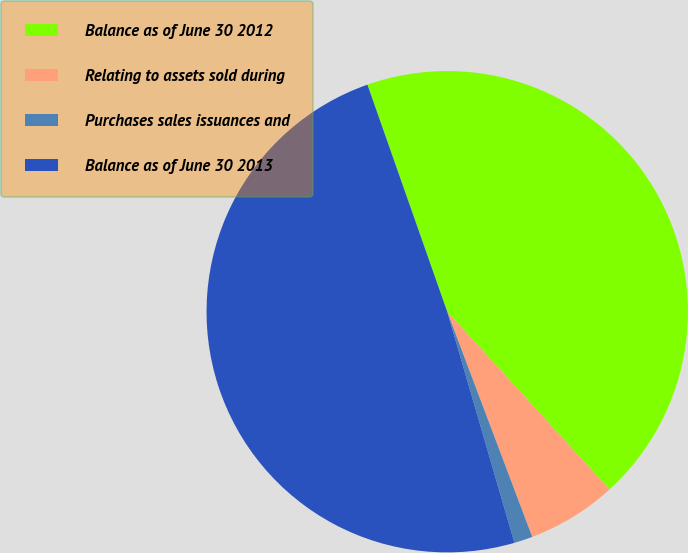Convert chart. <chart><loc_0><loc_0><loc_500><loc_500><pie_chart><fcel>Balance as of June 30 2012<fcel>Relating to assets sold during<fcel>Purchases sales issuances and<fcel>Balance as of June 30 2013<nl><fcel>43.61%<fcel>6.03%<fcel>1.24%<fcel>49.13%<nl></chart> 